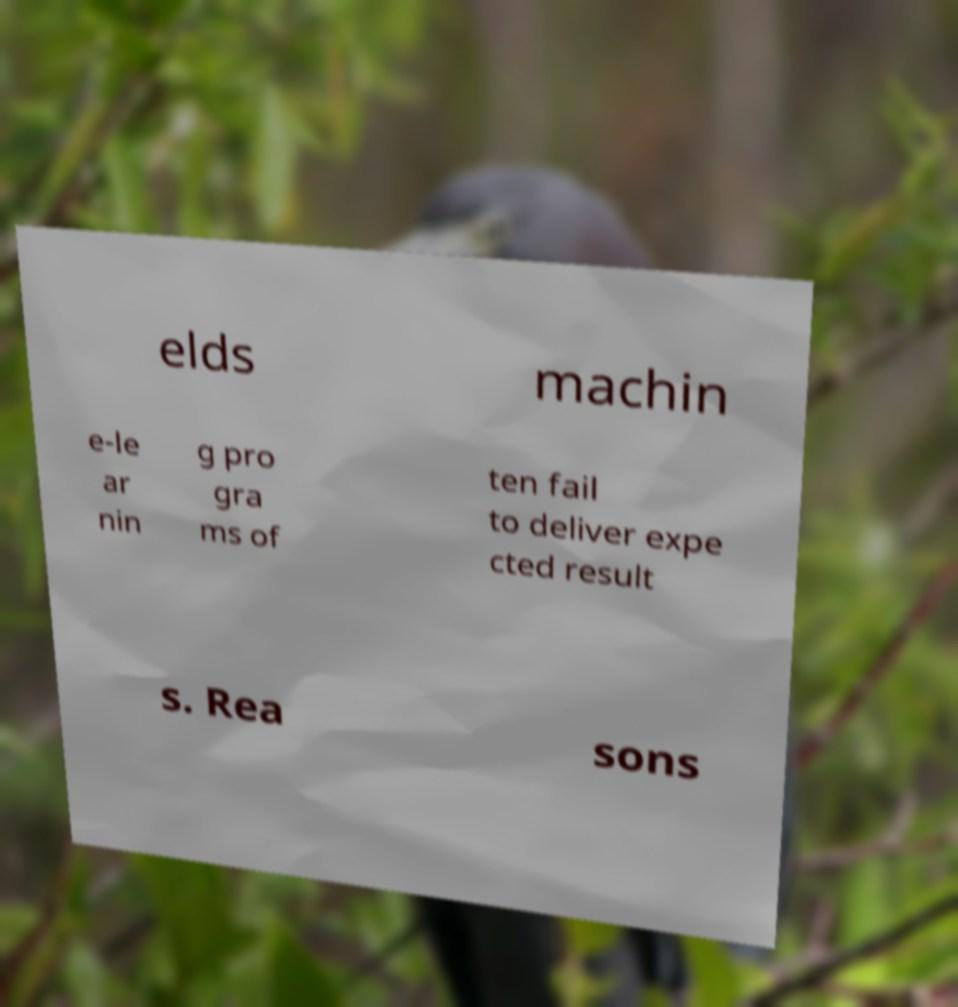Could you extract and type out the text from this image? elds machin e-le ar nin g pro gra ms of ten fail to deliver expe cted result s. Rea sons 